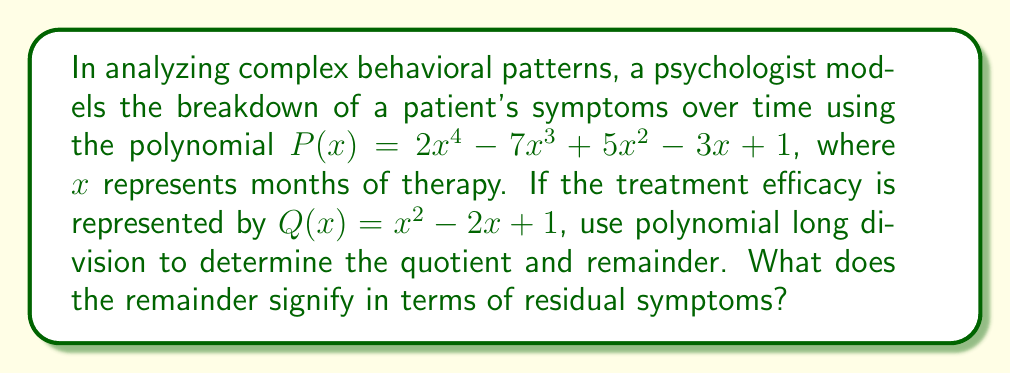Show me your answer to this math problem. Let's perform polynomial long division of $P(x)$ by $Q(x)$:

$$
\begin{array}{r}
2x^2 - 3x + 2 \\
x^2 - 2x + 1 \enclose{longdiv}{2x^4 - 7x^3 + 5x^2 - 3x + 1} \\
\underline{2x^4 - 4x^3 + 2x^2} \\
-3x^3 + 3x^2 - 3x + 1 \\
\underline{-3x^3 + 6x^2 - 3x} \\
-3x^2 + 1 \\
\underline{-3x^2 + 6x - 3} \\
-6x + 4
\end{array}
$$

1) First, divide $2x^4$ by $x^2$, getting $2x^2$.
2) Multiply $(2x^2)(x^2 - 2x + 1) = 2x^4 - 4x^3 + 2x^2$ and subtract.
3) Bring down the next term, divide $-3x^3$ by $x^2$, getting $-3x$.
4) Multiply $(-3x)(x^2 - 2x + 1) = -3x^3 + 6x^2 - 3x$ and subtract.
5) Bring down the next term, divide $-3x^2$ by $x^2$, getting $-3$.
6) Multiply $(-3)(x^2 - 2x + 1) = -3x^2 + 6x - 3$ and subtract.

The quotient is $2x^2 - 3x + 2$, and the remainder is $-6x + 4$.

In terms of residual symptoms, the remainder $-6x + 4$ represents the persistent behavioral patterns that do not respond to the primary treatment approach. The negative coefficient of $x$ suggests that these residual symptoms tend to decrease over time, while the constant term indicates a baseline level of symptoms that may persist.
Answer: Quotient: $2x^2 - 3x + 2$; Remainder: $-6x + 4$; The remainder represents decreasing residual symptoms over time with a persistent baseline. 